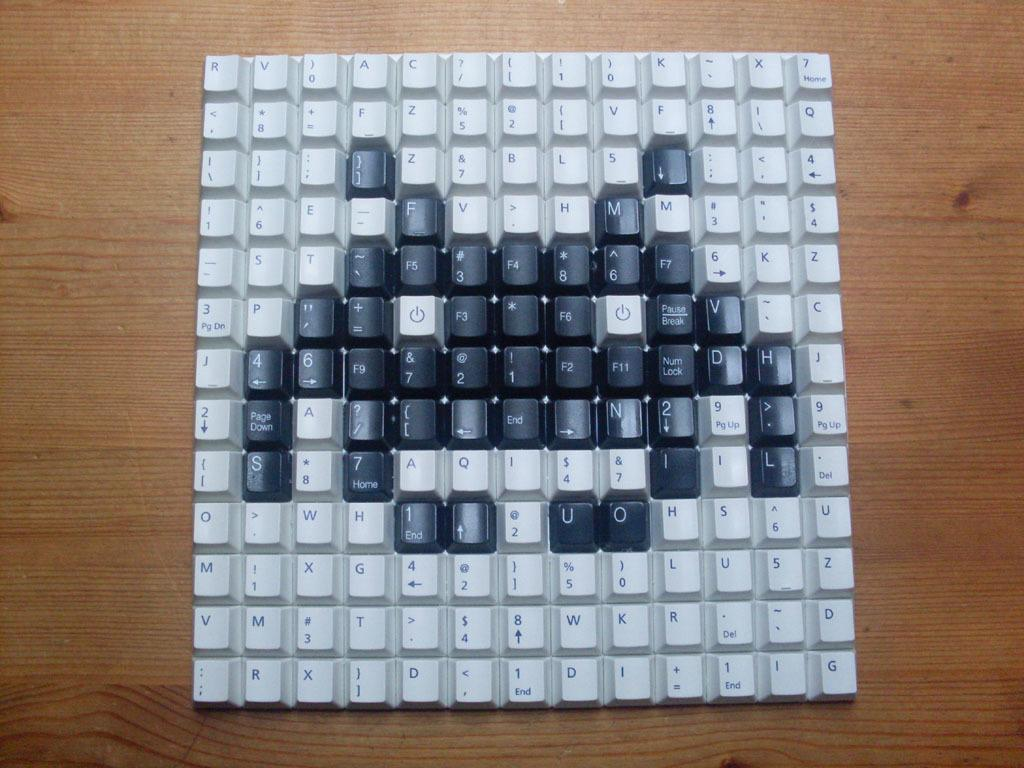<image>
Share a concise interpretation of the image provided. Many keyboard keys formed into a square with the power buttons in the middle. 